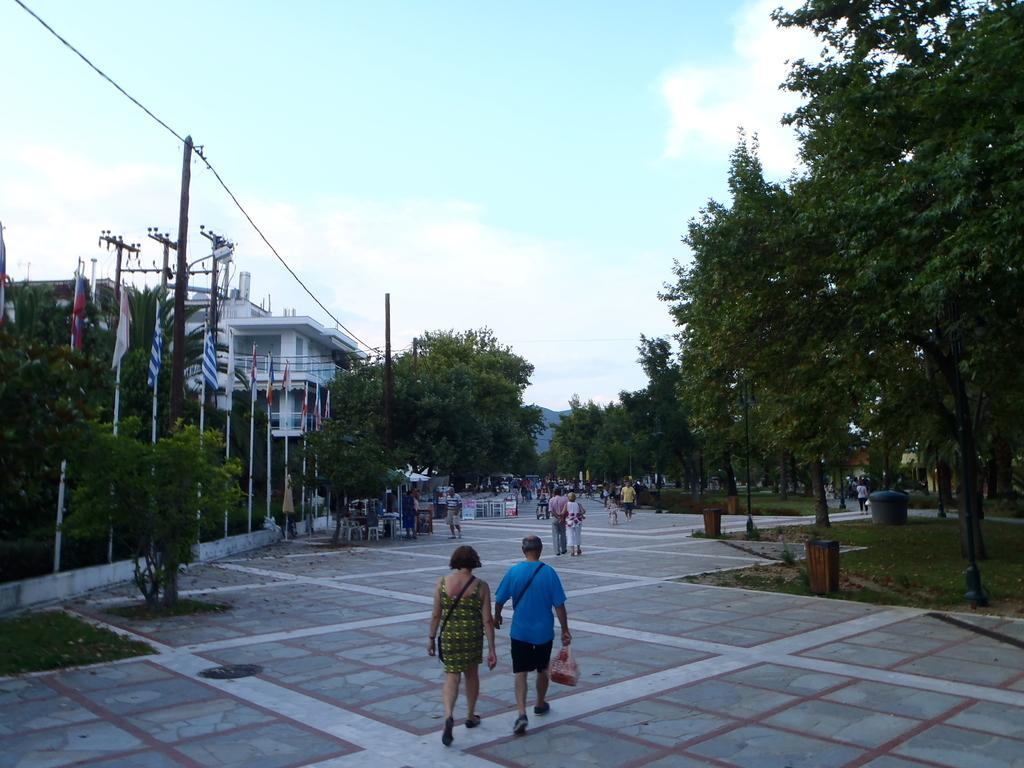In one or two sentences, can you explain what this image depicts? In this image we can see many people. Some are holding bags. On the sides there are trees. Also there are dustbins. On the left side we can see flags with poles and electric poles with wires. And there is a building. In the background there is sky with clouds. 